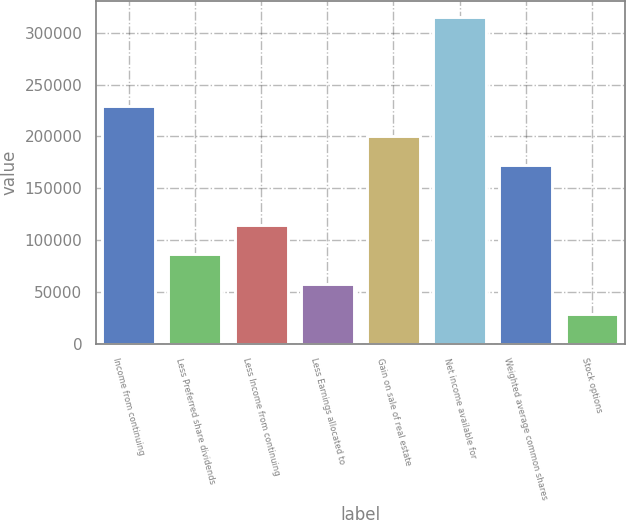<chart> <loc_0><loc_0><loc_500><loc_500><bar_chart><fcel>Income from continuing<fcel>Less Preferred share dividends<fcel>Less Income from continuing<fcel>Less Earnings allocated to<fcel>Gain on sale of real estate<fcel>Net income available for<fcel>Weighted average common shares<fcel>Stock options<nl><fcel>229212<fcel>85957<fcel>114608<fcel>57306<fcel>200561<fcel>315165<fcel>171910<fcel>28655<nl></chart> 